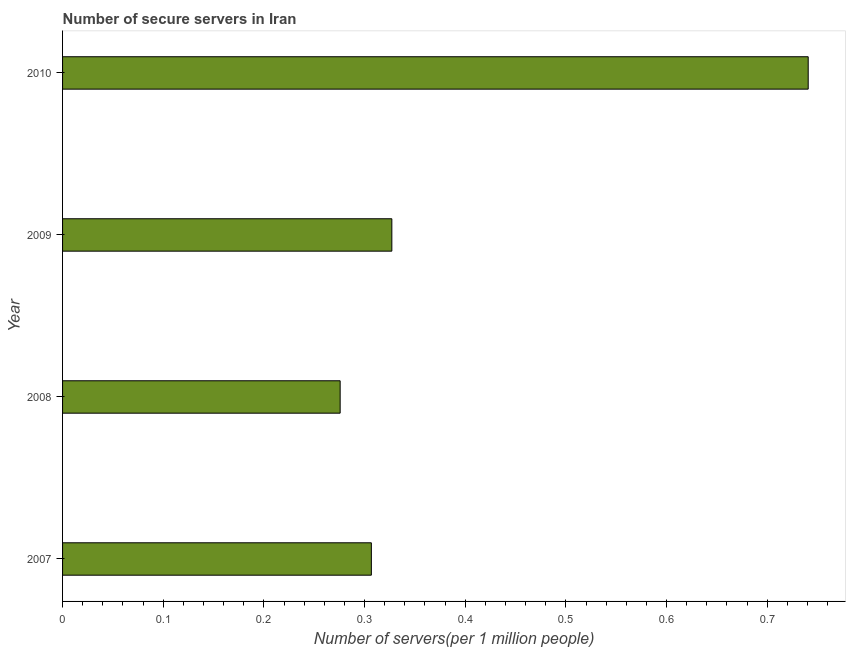Does the graph contain any zero values?
Provide a succinct answer. No. What is the title of the graph?
Provide a short and direct response. Number of secure servers in Iran. What is the label or title of the X-axis?
Your answer should be very brief. Number of servers(per 1 million people). What is the label or title of the Y-axis?
Make the answer very short. Year. What is the number of secure internet servers in 2008?
Your response must be concise. 0.28. Across all years, what is the maximum number of secure internet servers?
Give a very brief answer. 0.74. Across all years, what is the minimum number of secure internet servers?
Ensure brevity in your answer.  0.28. In which year was the number of secure internet servers maximum?
Provide a succinct answer. 2010. What is the sum of the number of secure internet servers?
Offer a very short reply. 1.65. What is the difference between the number of secure internet servers in 2008 and 2009?
Make the answer very short. -0.05. What is the average number of secure internet servers per year?
Your response must be concise. 0.41. What is the median number of secure internet servers?
Your answer should be very brief. 0.32. In how many years, is the number of secure internet servers greater than 0.42 ?
Offer a very short reply. 1. Do a majority of the years between 2008 and 2007 (inclusive) have number of secure internet servers greater than 0.46 ?
Your response must be concise. No. What is the ratio of the number of secure internet servers in 2007 to that in 2008?
Make the answer very short. 1.11. Is the number of secure internet servers in 2007 less than that in 2008?
Give a very brief answer. No. What is the difference between the highest and the second highest number of secure internet servers?
Your answer should be very brief. 0.41. Is the sum of the number of secure internet servers in 2008 and 2010 greater than the maximum number of secure internet servers across all years?
Provide a succinct answer. Yes. What is the difference between the highest and the lowest number of secure internet servers?
Make the answer very short. 0.46. In how many years, is the number of secure internet servers greater than the average number of secure internet servers taken over all years?
Provide a succinct answer. 1. Are all the bars in the graph horizontal?
Keep it short and to the point. Yes. How many years are there in the graph?
Make the answer very short. 4. What is the Number of servers(per 1 million people) in 2007?
Offer a terse response. 0.31. What is the Number of servers(per 1 million people) in 2008?
Keep it short and to the point. 0.28. What is the Number of servers(per 1 million people) of 2009?
Offer a very short reply. 0.33. What is the Number of servers(per 1 million people) in 2010?
Keep it short and to the point. 0.74. What is the difference between the Number of servers(per 1 million people) in 2007 and 2008?
Keep it short and to the point. 0.03. What is the difference between the Number of servers(per 1 million people) in 2007 and 2009?
Offer a terse response. -0.02. What is the difference between the Number of servers(per 1 million people) in 2007 and 2010?
Provide a short and direct response. -0.43. What is the difference between the Number of servers(per 1 million people) in 2008 and 2009?
Your answer should be compact. -0.05. What is the difference between the Number of servers(per 1 million people) in 2008 and 2010?
Keep it short and to the point. -0.46. What is the difference between the Number of servers(per 1 million people) in 2009 and 2010?
Offer a very short reply. -0.41. What is the ratio of the Number of servers(per 1 million people) in 2007 to that in 2008?
Your answer should be very brief. 1.11. What is the ratio of the Number of servers(per 1 million people) in 2007 to that in 2009?
Keep it short and to the point. 0.94. What is the ratio of the Number of servers(per 1 million people) in 2007 to that in 2010?
Provide a succinct answer. 0.41. What is the ratio of the Number of servers(per 1 million people) in 2008 to that in 2009?
Ensure brevity in your answer.  0.84. What is the ratio of the Number of servers(per 1 million people) in 2008 to that in 2010?
Make the answer very short. 0.37. What is the ratio of the Number of servers(per 1 million people) in 2009 to that in 2010?
Keep it short and to the point. 0.44. 